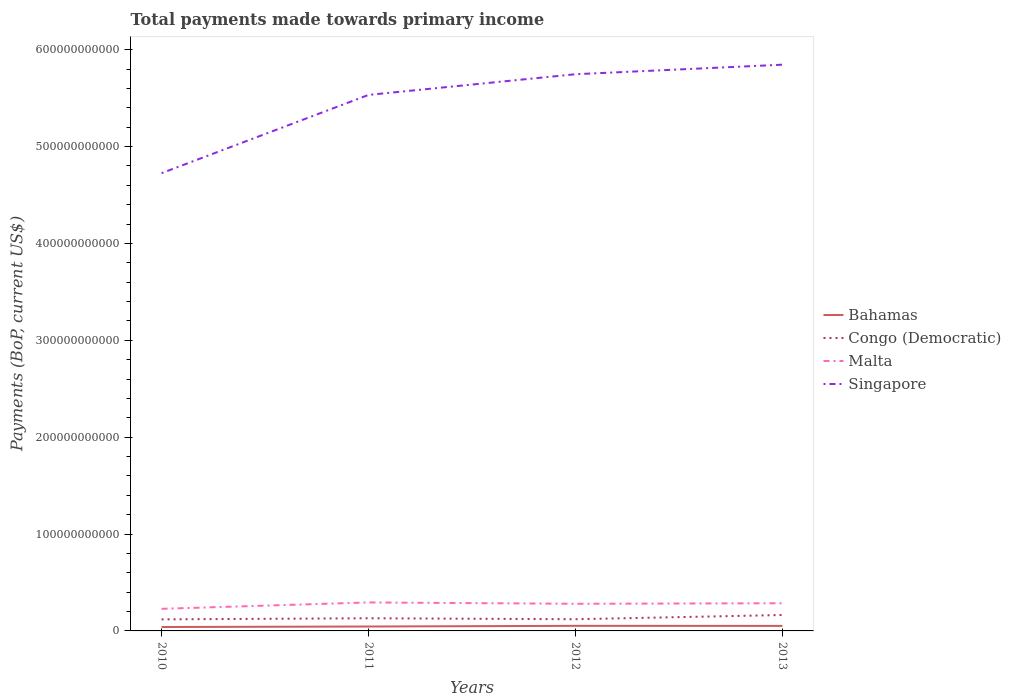Is the number of lines equal to the number of legend labels?
Provide a succinct answer. Yes. Across all years, what is the maximum total payments made towards primary income in Congo (Democratic)?
Offer a very short reply. 1.19e+1. In which year was the total payments made towards primary income in Congo (Democratic) maximum?
Your response must be concise. 2010. What is the total total payments made towards primary income in Congo (Democratic) in the graph?
Provide a short and direct response. 9.96e+08. What is the difference between the highest and the second highest total payments made towards primary income in Malta?
Offer a terse response. 6.59e+09. Is the total payments made towards primary income in Malta strictly greater than the total payments made towards primary income in Congo (Democratic) over the years?
Offer a terse response. No. How many lines are there?
Your answer should be very brief. 4. How many years are there in the graph?
Provide a succinct answer. 4. What is the difference between two consecutive major ticks on the Y-axis?
Offer a very short reply. 1.00e+11. Does the graph contain grids?
Provide a succinct answer. No. Where does the legend appear in the graph?
Offer a very short reply. Center right. How are the legend labels stacked?
Offer a very short reply. Vertical. What is the title of the graph?
Offer a very short reply. Total payments made towards primary income. What is the label or title of the X-axis?
Ensure brevity in your answer.  Years. What is the label or title of the Y-axis?
Give a very brief answer. Payments (BoP, current US$). What is the Payments (BoP, current US$) of Bahamas in 2010?
Provide a succinct answer. 4.05e+09. What is the Payments (BoP, current US$) of Congo (Democratic) in 2010?
Your response must be concise. 1.19e+1. What is the Payments (BoP, current US$) in Malta in 2010?
Your response must be concise. 2.28e+1. What is the Payments (BoP, current US$) in Singapore in 2010?
Keep it short and to the point. 4.73e+11. What is the Payments (BoP, current US$) of Bahamas in 2011?
Your answer should be compact. 4.55e+09. What is the Payments (BoP, current US$) in Congo (Democratic) in 2011?
Your answer should be very brief. 1.31e+1. What is the Payments (BoP, current US$) of Malta in 2011?
Give a very brief answer. 2.94e+1. What is the Payments (BoP, current US$) in Singapore in 2011?
Offer a terse response. 5.53e+11. What is the Payments (BoP, current US$) of Bahamas in 2012?
Give a very brief answer. 5.24e+09. What is the Payments (BoP, current US$) in Congo (Democratic) in 2012?
Keep it short and to the point. 1.21e+1. What is the Payments (BoP, current US$) in Malta in 2012?
Give a very brief answer. 2.80e+1. What is the Payments (BoP, current US$) of Singapore in 2012?
Make the answer very short. 5.75e+11. What is the Payments (BoP, current US$) of Bahamas in 2013?
Your answer should be compact. 5.17e+09. What is the Payments (BoP, current US$) in Congo (Democratic) in 2013?
Your answer should be compact. 1.64e+1. What is the Payments (BoP, current US$) in Malta in 2013?
Provide a short and direct response. 2.86e+1. What is the Payments (BoP, current US$) in Singapore in 2013?
Give a very brief answer. 5.85e+11. Across all years, what is the maximum Payments (BoP, current US$) of Bahamas?
Make the answer very short. 5.24e+09. Across all years, what is the maximum Payments (BoP, current US$) of Congo (Democratic)?
Your response must be concise. 1.64e+1. Across all years, what is the maximum Payments (BoP, current US$) in Malta?
Provide a short and direct response. 2.94e+1. Across all years, what is the maximum Payments (BoP, current US$) in Singapore?
Your response must be concise. 5.85e+11. Across all years, what is the minimum Payments (BoP, current US$) in Bahamas?
Your answer should be compact. 4.05e+09. Across all years, what is the minimum Payments (BoP, current US$) of Congo (Democratic)?
Offer a terse response. 1.19e+1. Across all years, what is the minimum Payments (BoP, current US$) in Malta?
Your answer should be very brief. 2.28e+1. Across all years, what is the minimum Payments (BoP, current US$) of Singapore?
Keep it short and to the point. 4.73e+11. What is the total Payments (BoP, current US$) in Bahamas in the graph?
Give a very brief answer. 1.90e+1. What is the total Payments (BoP, current US$) of Congo (Democratic) in the graph?
Your response must be concise. 5.35e+1. What is the total Payments (BoP, current US$) in Malta in the graph?
Offer a terse response. 1.09e+11. What is the total Payments (BoP, current US$) in Singapore in the graph?
Your response must be concise. 2.19e+12. What is the difference between the Payments (BoP, current US$) of Bahamas in 2010 and that in 2011?
Ensure brevity in your answer.  -5.03e+08. What is the difference between the Payments (BoP, current US$) of Congo (Democratic) in 2010 and that in 2011?
Offer a terse response. -1.14e+09. What is the difference between the Payments (BoP, current US$) of Malta in 2010 and that in 2011?
Your answer should be compact. -6.59e+09. What is the difference between the Payments (BoP, current US$) of Singapore in 2010 and that in 2011?
Provide a short and direct response. -8.08e+1. What is the difference between the Payments (BoP, current US$) of Bahamas in 2010 and that in 2012?
Keep it short and to the point. -1.19e+09. What is the difference between the Payments (BoP, current US$) of Congo (Democratic) in 2010 and that in 2012?
Your answer should be compact. -1.44e+08. What is the difference between the Payments (BoP, current US$) of Malta in 2010 and that in 2012?
Ensure brevity in your answer.  -5.20e+09. What is the difference between the Payments (BoP, current US$) of Singapore in 2010 and that in 2012?
Make the answer very short. -1.02e+11. What is the difference between the Payments (BoP, current US$) of Bahamas in 2010 and that in 2013?
Give a very brief answer. -1.13e+09. What is the difference between the Payments (BoP, current US$) in Congo (Democratic) in 2010 and that in 2013?
Provide a short and direct response. -4.50e+09. What is the difference between the Payments (BoP, current US$) of Malta in 2010 and that in 2013?
Ensure brevity in your answer.  -5.75e+09. What is the difference between the Payments (BoP, current US$) in Singapore in 2010 and that in 2013?
Your answer should be compact. -1.12e+11. What is the difference between the Payments (BoP, current US$) in Bahamas in 2011 and that in 2012?
Provide a short and direct response. -6.91e+08. What is the difference between the Payments (BoP, current US$) of Congo (Democratic) in 2011 and that in 2012?
Ensure brevity in your answer.  9.96e+08. What is the difference between the Payments (BoP, current US$) of Malta in 2011 and that in 2012?
Make the answer very short. 1.39e+09. What is the difference between the Payments (BoP, current US$) in Singapore in 2011 and that in 2012?
Ensure brevity in your answer.  -2.13e+1. What is the difference between the Payments (BoP, current US$) of Bahamas in 2011 and that in 2013?
Your answer should be very brief. -6.22e+08. What is the difference between the Payments (BoP, current US$) in Congo (Democratic) in 2011 and that in 2013?
Provide a succinct answer. -3.36e+09. What is the difference between the Payments (BoP, current US$) of Malta in 2011 and that in 2013?
Ensure brevity in your answer.  8.37e+08. What is the difference between the Payments (BoP, current US$) in Singapore in 2011 and that in 2013?
Make the answer very short. -3.12e+1. What is the difference between the Payments (BoP, current US$) of Bahamas in 2012 and that in 2013?
Provide a short and direct response. 6.91e+07. What is the difference between the Payments (BoP, current US$) in Congo (Democratic) in 2012 and that in 2013?
Provide a succinct answer. -4.35e+09. What is the difference between the Payments (BoP, current US$) of Malta in 2012 and that in 2013?
Give a very brief answer. -5.52e+08. What is the difference between the Payments (BoP, current US$) in Singapore in 2012 and that in 2013?
Ensure brevity in your answer.  -9.84e+09. What is the difference between the Payments (BoP, current US$) of Bahamas in 2010 and the Payments (BoP, current US$) of Congo (Democratic) in 2011?
Keep it short and to the point. -9.02e+09. What is the difference between the Payments (BoP, current US$) of Bahamas in 2010 and the Payments (BoP, current US$) of Malta in 2011?
Keep it short and to the point. -2.54e+1. What is the difference between the Payments (BoP, current US$) in Bahamas in 2010 and the Payments (BoP, current US$) in Singapore in 2011?
Make the answer very short. -5.49e+11. What is the difference between the Payments (BoP, current US$) of Congo (Democratic) in 2010 and the Payments (BoP, current US$) of Malta in 2011?
Your answer should be very brief. -1.75e+1. What is the difference between the Payments (BoP, current US$) in Congo (Democratic) in 2010 and the Payments (BoP, current US$) in Singapore in 2011?
Your answer should be compact. -5.41e+11. What is the difference between the Payments (BoP, current US$) of Malta in 2010 and the Payments (BoP, current US$) of Singapore in 2011?
Provide a succinct answer. -5.31e+11. What is the difference between the Payments (BoP, current US$) of Bahamas in 2010 and the Payments (BoP, current US$) of Congo (Democratic) in 2012?
Make the answer very short. -8.03e+09. What is the difference between the Payments (BoP, current US$) in Bahamas in 2010 and the Payments (BoP, current US$) in Malta in 2012?
Keep it short and to the point. -2.40e+1. What is the difference between the Payments (BoP, current US$) of Bahamas in 2010 and the Payments (BoP, current US$) of Singapore in 2012?
Provide a short and direct response. -5.71e+11. What is the difference between the Payments (BoP, current US$) in Congo (Democratic) in 2010 and the Payments (BoP, current US$) in Malta in 2012?
Offer a terse response. -1.61e+1. What is the difference between the Payments (BoP, current US$) in Congo (Democratic) in 2010 and the Payments (BoP, current US$) in Singapore in 2012?
Provide a succinct answer. -5.63e+11. What is the difference between the Payments (BoP, current US$) of Malta in 2010 and the Payments (BoP, current US$) of Singapore in 2012?
Your answer should be very brief. -5.52e+11. What is the difference between the Payments (BoP, current US$) in Bahamas in 2010 and the Payments (BoP, current US$) in Congo (Democratic) in 2013?
Offer a terse response. -1.24e+1. What is the difference between the Payments (BoP, current US$) in Bahamas in 2010 and the Payments (BoP, current US$) in Malta in 2013?
Your answer should be very brief. -2.45e+1. What is the difference between the Payments (BoP, current US$) in Bahamas in 2010 and the Payments (BoP, current US$) in Singapore in 2013?
Provide a succinct answer. -5.81e+11. What is the difference between the Payments (BoP, current US$) in Congo (Democratic) in 2010 and the Payments (BoP, current US$) in Malta in 2013?
Provide a succinct answer. -1.66e+1. What is the difference between the Payments (BoP, current US$) in Congo (Democratic) in 2010 and the Payments (BoP, current US$) in Singapore in 2013?
Your response must be concise. -5.73e+11. What is the difference between the Payments (BoP, current US$) of Malta in 2010 and the Payments (BoP, current US$) of Singapore in 2013?
Ensure brevity in your answer.  -5.62e+11. What is the difference between the Payments (BoP, current US$) of Bahamas in 2011 and the Payments (BoP, current US$) of Congo (Democratic) in 2012?
Give a very brief answer. -7.53e+09. What is the difference between the Payments (BoP, current US$) in Bahamas in 2011 and the Payments (BoP, current US$) in Malta in 2012?
Your response must be concise. -2.35e+1. What is the difference between the Payments (BoP, current US$) of Bahamas in 2011 and the Payments (BoP, current US$) of Singapore in 2012?
Offer a very short reply. -5.70e+11. What is the difference between the Payments (BoP, current US$) of Congo (Democratic) in 2011 and the Payments (BoP, current US$) of Malta in 2012?
Offer a terse response. -1.49e+1. What is the difference between the Payments (BoP, current US$) of Congo (Democratic) in 2011 and the Payments (BoP, current US$) of Singapore in 2012?
Offer a terse response. -5.62e+11. What is the difference between the Payments (BoP, current US$) of Malta in 2011 and the Payments (BoP, current US$) of Singapore in 2012?
Your answer should be compact. -5.45e+11. What is the difference between the Payments (BoP, current US$) in Bahamas in 2011 and the Payments (BoP, current US$) in Congo (Democratic) in 2013?
Give a very brief answer. -1.19e+1. What is the difference between the Payments (BoP, current US$) of Bahamas in 2011 and the Payments (BoP, current US$) of Malta in 2013?
Keep it short and to the point. -2.40e+1. What is the difference between the Payments (BoP, current US$) in Bahamas in 2011 and the Payments (BoP, current US$) in Singapore in 2013?
Provide a short and direct response. -5.80e+11. What is the difference between the Payments (BoP, current US$) in Congo (Democratic) in 2011 and the Payments (BoP, current US$) in Malta in 2013?
Ensure brevity in your answer.  -1.55e+1. What is the difference between the Payments (BoP, current US$) of Congo (Democratic) in 2011 and the Payments (BoP, current US$) of Singapore in 2013?
Your answer should be very brief. -5.72e+11. What is the difference between the Payments (BoP, current US$) of Malta in 2011 and the Payments (BoP, current US$) of Singapore in 2013?
Give a very brief answer. -5.55e+11. What is the difference between the Payments (BoP, current US$) in Bahamas in 2012 and the Payments (BoP, current US$) in Congo (Democratic) in 2013?
Offer a terse response. -1.12e+1. What is the difference between the Payments (BoP, current US$) in Bahamas in 2012 and the Payments (BoP, current US$) in Malta in 2013?
Give a very brief answer. -2.33e+1. What is the difference between the Payments (BoP, current US$) of Bahamas in 2012 and the Payments (BoP, current US$) of Singapore in 2013?
Your answer should be very brief. -5.79e+11. What is the difference between the Payments (BoP, current US$) in Congo (Democratic) in 2012 and the Payments (BoP, current US$) in Malta in 2013?
Your answer should be compact. -1.65e+1. What is the difference between the Payments (BoP, current US$) in Congo (Democratic) in 2012 and the Payments (BoP, current US$) in Singapore in 2013?
Your answer should be compact. -5.72e+11. What is the difference between the Payments (BoP, current US$) of Malta in 2012 and the Payments (BoP, current US$) of Singapore in 2013?
Offer a very short reply. -5.57e+11. What is the average Payments (BoP, current US$) of Bahamas per year?
Make the answer very short. 4.75e+09. What is the average Payments (BoP, current US$) of Congo (Democratic) per year?
Provide a succinct answer. 1.34e+1. What is the average Payments (BoP, current US$) of Malta per year?
Make the answer very short. 2.72e+1. What is the average Payments (BoP, current US$) of Singapore per year?
Your response must be concise. 5.46e+11. In the year 2010, what is the difference between the Payments (BoP, current US$) of Bahamas and Payments (BoP, current US$) of Congo (Democratic)?
Keep it short and to the point. -7.88e+09. In the year 2010, what is the difference between the Payments (BoP, current US$) of Bahamas and Payments (BoP, current US$) of Malta?
Offer a very short reply. -1.88e+1. In the year 2010, what is the difference between the Payments (BoP, current US$) of Bahamas and Payments (BoP, current US$) of Singapore?
Your response must be concise. -4.69e+11. In the year 2010, what is the difference between the Payments (BoP, current US$) of Congo (Democratic) and Payments (BoP, current US$) of Malta?
Offer a very short reply. -1.09e+1. In the year 2010, what is the difference between the Payments (BoP, current US$) in Congo (Democratic) and Payments (BoP, current US$) in Singapore?
Provide a succinct answer. -4.61e+11. In the year 2010, what is the difference between the Payments (BoP, current US$) of Malta and Payments (BoP, current US$) of Singapore?
Offer a very short reply. -4.50e+11. In the year 2011, what is the difference between the Payments (BoP, current US$) in Bahamas and Payments (BoP, current US$) in Congo (Democratic)?
Offer a very short reply. -8.52e+09. In the year 2011, what is the difference between the Payments (BoP, current US$) of Bahamas and Payments (BoP, current US$) of Malta?
Ensure brevity in your answer.  -2.49e+1. In the year 2011, what is the difference between the Payments (BoP, current US$) in Bahamas and Payments (BoP, current US$) in Singapore?
Keep it short and to the point. -5.49e+11. In the year 2011, what is the difference between the Payments (BoP, current US$) of Congo (Democratic) and Payments (BoP, current US$) of Malta?
Your answer should be very brief. -1.63e+1. In the year 2011, what is the difference between the Payments (BoP, current US$) in Congo (Democratic) and Payments (BoP, current US$) in Singapore?
Offer a terse response. -5.40e+11. In the year 2011, what is the difference between the Payments (BoP, current US$) of Malta and Payments (BoP, current US$) of Singapore?
Provide a succinct answer. -5.24e+11. In the year 2012, what is the difference between the Payments (BoP, current US$) of Bahamas and Payments (BoP, current US$) of Congo (Democratic)?
Ensure brevity in your answer.  -6.83e+09. In the year 2012, what is the difference between the Payments (BoP, current US$) of Bahamas and Payments (BoP, current US$) of Malta?
Your answer should be compact. -2.28e+1. In the year 2012, what is the difference between the Payments (BoP, current US$) of Bahamas and Payments (BoP, current US$) of Singapore?
Offer a very short reply. -5.69e+11. In the year 2012, what is the difference between the Payments (BoP, current US$) in Congo (Democratic) and Payments (BoP, current US$) in Malta?
Provide a short and direct response. -1.59e+1. In the year 2012, what is the difference between the Payments (BoP, current US$) of Congo (Democratic) and Payments (BoP, current US$) of Singapore?
Provide a short and direct response. -5.63e+11. In the year 2012, what is the difference between the Payments (BoP, current US$) in Malta and Payments (BoP, current US$) in Singapore?
Provide a succinct answer. -5.47e+11. In the year 2013, what is the difference between the Payments (BoP, current US$) in Bahamas and Payments (BoP, current US$) in Congo (Democratic)?
Your answer should be compact. -1.13e+1. In the year 2013, what is the difference between the Payments (BoP, current US$) in Bahamas and Payments (BoP, current US$) in Malta?
Ensure brevity in your answer.  -2.34e+1. In the year 2013, what is the difference between the Payments (BoP, current US$) in Bahamas and Payments (BoP, current US$) in Singapore?
Offer a very short reply. -5.79e+11. In the year 2013, what is the difference between the Payments (BoP, current US$) in Congo (Democratic) and Payments (BoP, current US$) in Malta?
Give a very brief answer. -1.21e+1. In the year 2013, what is the difference between the Payments (BoP, current US$) of Congo (Democratic) and Payments (BoP, current US$) of Singapore?
Make the answer very short. -5.68e+11. In the year 2013, what is the difference between the Payments (BoP, current US$) of Malta and Payments (BoP, current US$) of Singapore?
Make the answer very short. -5.56e+11. What is the ratio of the Payments (BoP, current US$) in Bahamas in 2010 to that in 2011?
Offer a terse response. 0.89. What is the ratio of the Payments (BoP, current US$) in Congo (Democratic) in 2010 to that in 2011?
Make the answer very short. 0.91. What is the ratio of the Payments (BoP, current US$) of Malta in 2010 to that in 2011?
Offer a very short reply. 0.78. What is the ratio of the Payments (BoP, current US$) in Singapore in 2010 to that in 2011?
Your answer should be very brief. 0.85. What is the ratio of the Payments (BoP, current US$) in Bahamas in 2010 to that in 2012?
Keep it short and to the point. 0.77. What is the ratio of the Payments (BoP, current US$) in Congo (Democratic) in 2010 to that in 2012?
Your answer should be very brief. 0.99. What is the ratio of the Payments (BoP, current US$) of Malta in 2010 to that in 2012?
Your answer should be very brief. 0.81. What is the ratio of the Payments (BoP, current US$) of Singapore in 2010 to that in 2012?
Your response must be concise. 0.82. What is the ratio of the Payments (BoP, current US$) in Bahamas in 2010 to that in 2013?
Give a very brief answer. 0.78. What is the ratio of the Payments (BoP, current US$) of Congo (Democratic) in 2010 to that in 2013?
Keep it short and to the point. 0.73. What is the ratio of the Payments (BoP, current US$) of Malta in 2010 to that in 2013?
Make the answer very short. 0.8. What is the ratio of the Payments (BoP, current US$) of Singapore in 2010 to that in 2013?
Your response must be concise. 0.81. What is the ratio of the Payments (BoP, current US$) in Bahamas in 2011 to that in 2012?
Provide a short and direct response. 0.87. What is the ratio of the Payments (BoP, current US$) in Congo (Democratic) in 2011 to that in 2012?
Provide a short and direct response. 1.08. What is the ratio of the Payments (BoP, current US$) in Malta in 2011 to that in 2012?
Your response must be concise. 1.05. What is the ratio of the Payments (BoP, current US$) of Singapore in 2011 to that in 2012?
Offer a very short reply. 0.96. What is the ratio of the Payments (BoP, current US$) of Bahamas in 2011 to that in 2013?
Provide a short and direct response. 0.88. What is the ratio of the Payments (BoP, current US$) in Congo (Democratic) in 2011 to that in 2013?
Keep it short and to the point. 0.8. What is the ratio of the Payments (BoP, current US$) of Malta in 2011 to that in 2013?
Give a very brief answer. 1.03. What is the ratio of the Payments (BoP, current US$) of Singapore in 2011 to that in 2013?
Offer a terse response. 0.95. What is the ratio of the Payments (BoP, current US$) of Bahamas in 2012 to that in 2013?
Ensure brevity in your answer.  1.01. What is the ratio of the Payments (BoP, current US$) of Congo (Democratic) in 2012 to that in 2013?
Your response must be concise. 0.73. What is the ratio of the Payments (BoP, current US$) in Malta in 2012 to that in 2013?
Make the answer very short. 0.98. What is the ratio of the Payments (BoP, current US$) of Singapore in 2012 to that in 2013?
Provide a succinct answer. 0.98. What is the difference between the highest and the second highest Payments (BoP, current US$) in Bahamas?
Give a very brief answer. 6.91e+07. What is the difference between the highest and the second highest Payments (BoP, current US$) in Congo (Democratic)?
Provide a short and direct response. 3.36e+09. What is the difference between the highest and the second highest Payments (BoP, current US$) of Malta?
Your answer should be compact. 8.37e+08. What is the difference between the highest and the second highest Payments (BoP, current US$) of Singapore?
Ensure brevity in your answer.  9.84e+09. What is the difference between the highest and the lowest Payments (BoP, current US$) in Bahamas?
Ensure brevity in your answer.  1.19e+09. What is the difference between the highest and the lowest Payments (BoP, current US$) in Congo (Democratic)?
Provide a short and direct response. 4.50e+09. What is the difference between the highest and the lowest Payments (BoP, current US$) in Malta?
Your response must be concise. 6.59e+09. What is the difference between the highest and the lowest Payments (BoP, current US$) of Singapore?
Your response must be concise. 1.12e+11. 